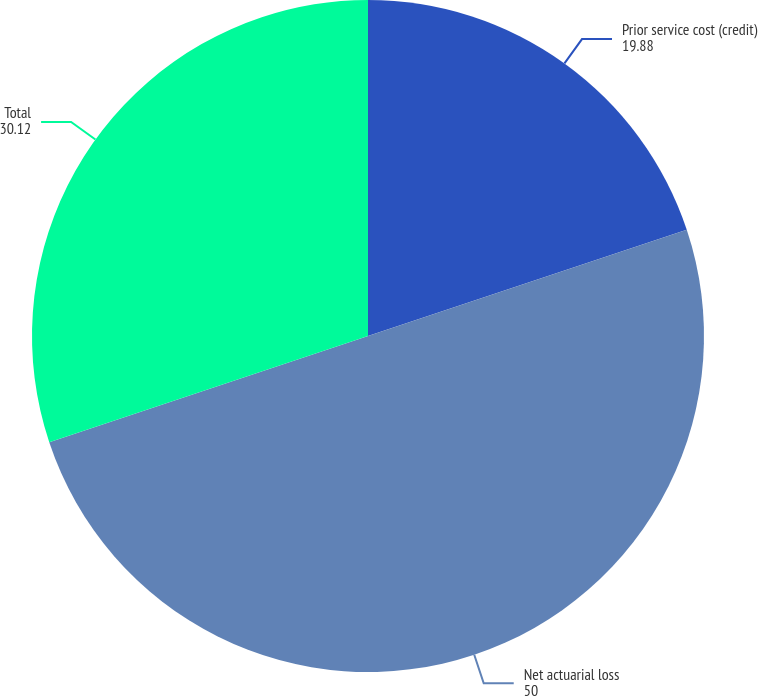Convert chart to OTSL. <chart><loc_0><loc_0><loc_500><loc_500><pie_chart><fcel>Prior service cost (credit)<fcel>Net actuarial loss<fcel>Total<nl><fcel>19.88%<fcel>50.0%<fcel>30.12%<nl></chart> 